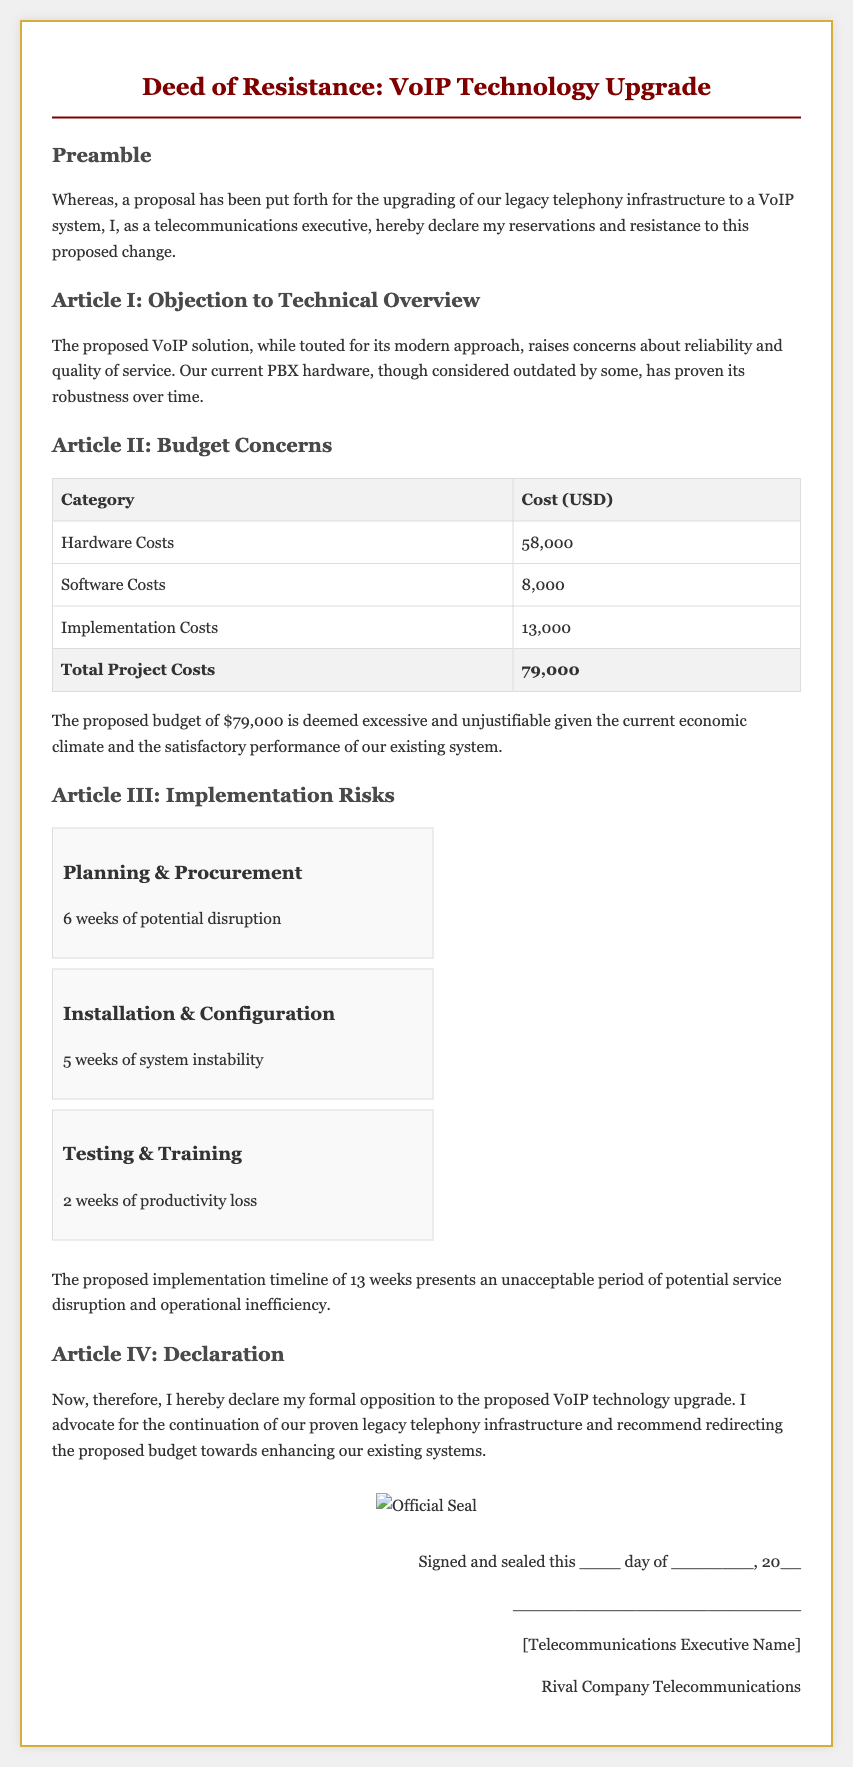What is the total project cost? The total project cost is stated in the budget section of the document, which is $79,000.
Answer: $79,000 How many weeks is the implementation timeline? The implementation timeline, as outlined in the document, totals 13 weeks.
Answer: 13 weeks What is the cost for hardware? The budget table lists the hardware costs, which amount to $58,000.
Answer: $58,000 What section details the risks associated with implementation? The section "Article III: Implementation Risks" discusses the risks related to the implementation process.
Answer: Article III: Implementation Risks What is the potential disruption time for Planning & Procurement? The document specifies that Planning & Procurement could cause 6 weeks of potential disruption.
Answer: 6 weeks What is the formal position of the telecommunications executive? The executive's formal position is opposition to the proposed VoIP technology upgrade.
Answer: Opposition How many weeks of productivity loss are expected during Testing & Training? The document mentions an expected productivity loss of 2 weeks during Testing & Training.
Answer: 2 weeks What is the name of the document? The title of the document is provided at the top as "Deed of Resistance: VoIP Technology Upgrade."
Answer: Deed of Resistance: VoIP Technology Upgrade What does the executive advocate for instead of VoIP technology? The executive advocates for the continuation of the existing legacy telephony infrastructure.
Answer: Continuation of the existing legacy telephony infrastructure 